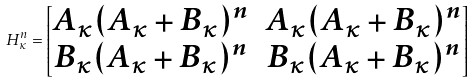Convert formula to latex. <formula><loc_0><loc_0><loc_500><loc_500>H _ { \kappa } ^ { n } = \begin{bmatrix} A _ { \kappa } ( A _ { \kappa } + B _ { \kappa } ) ^ { n } & A _ { \kappa } ( A _ { \kappa } + B _ { \kappa } ) ^ { n } \\ B _ { \kappa } ( A _ { \kappa } + B _ { \kappa } ) ^ { n } & B _ { \kappa } ( A _ { \kappa } + B _ { \kappa } ) ^ { n } \end{bmatrix}</formula> 